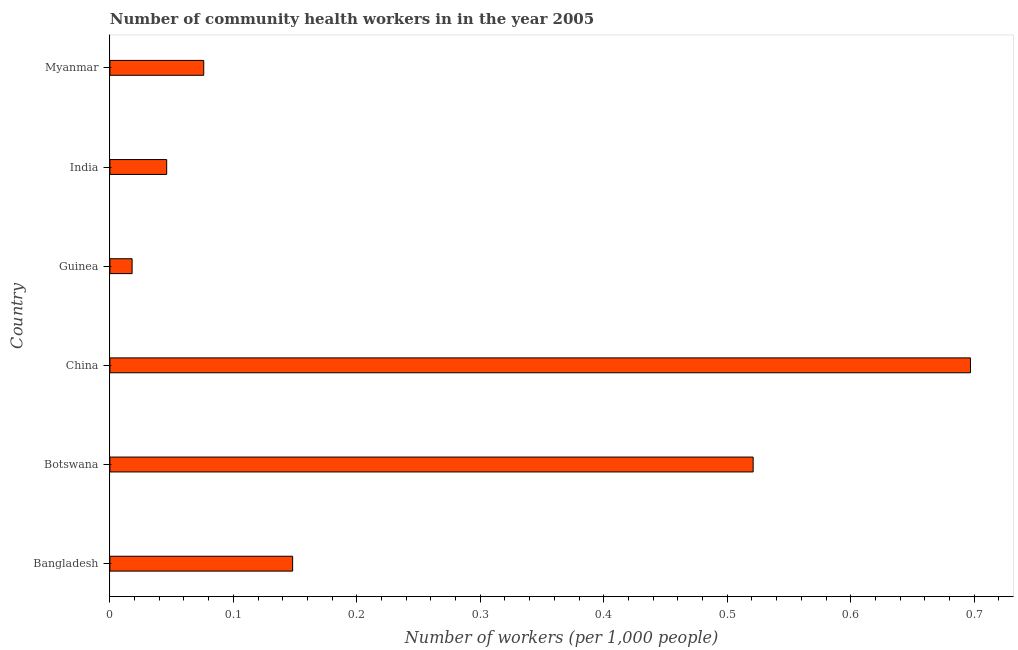Does the graph contain any zero values?
Give a very brief answer. No. What is the title of the graph?
Provide a short and direct response. Number of community health workers in in the year 2005. What is the label or title of the X-axis?
Provide a succinct answer. Number of workers (per 1,0 people). What is the label or title of the Y-axis?
Provide a succinct answer. Country. What is the number of community health workers in Guinea?
Your response must be concise. 0.02. Across all countries, what is the maximum number of community health workers?
Keep it short and to the point. 0.7. Across all countries, what is the minimum number of community health workers?
Ensure brevity in your answer.  0.02. In which country was the number of community health workers maximum?
Your response must be concise. China. In which country was the number of community health workers minimum?
Ensure brevity in your answer.  Guinea. What is the sum of the number of community health workers?
Offer a very short reply. 1.51. What is the difference between the number of community health workers in Bangladesh and Guinea?
Offer a terse response. 0.13. What is the average number of community health workers per country?
Your answer should be very brief. 0.25. What is the median number of community health workers?
Make the answer very short. 0.11. In how many countries, is the number of community health workers greater than 0.42 ?
Your response must be concise. 2. What is the ratio of the number of community health workers in Bangladesh to that in Myanmar?
Provide a succinct answer. 1.95. Is the number of community health workers in Botswana less than that in Guinea?
Your answer should be very brief. No. What is the difference between the highest and the second highest number of community health workers?
Your answer should be compact. 0.18. Is the sum of the number of community health workers in Bangladesh and Botswana greater than the maximum number of community health workers across all countries?
Give a very brief answer. No. What is the difference between the highest and the lowest number of community health workers?
Your response must be concise. 0.68. How many bars are there?
Your answer should be compact. 6. How many countries are there in the graph?
Make the answer very short. 6. Are the values on the major ticks of X-axis written in scientific E-notation?
Keep it short and to the point. No. What is the Number of workers (per 1,000 people) in Bangladesh?
Your answer should be very brief. 0.15. What is the Number of workers (per 1,000 people) in Botswana?
Offer a very short reply. 0.52. What is the Number of workers (per 1,000 people) of China?
Your answer should be compact. 0.7. What is the Number of workers (per 1,000 people) of Guinea?
Provide a succinct answer. 0.02. What is the Number of workers (per 1,000 people) of India?
Offer a very short reply. 0.05. What is the Number of workers (per 1,000 people) of Myanmar?
Your answer should be very brief. 0.08. What is the difference between the Number of workers (per 1,000 people) in Bangladesh and Botswana?
Keep it short and to the point. -0.37. What is the difference between the Number of workers (per 1,000 people) in Bangladesh and China?
Your response must be concise. -0.55. What is the difference between the Number of workers (per 1,000 people) in Bangladesh and Guinea?
Your answer should be compact. 0.13. What is the difference between the Number of workers (per 1,000 people) in Bangladesh and India?
Your answer should be compact. 0.1. What is the difference between the Number of workers (per 1,000 people) in Bangladesh and Myanmar?
Offer a terse response. 0.07. What is the difference between the Number of workers (per 1,000 people) in Botswana and China?
Give a very brief answer. -0.18. What is the difference between the Number of workers (per 1,000 people) in Botswana and Guinea?
Provide a succinct answer. 0.5. What is the difference between the Number of workers (per 1,000 people) in Botswana and India?
Provide a short and direct response. 0.47. What is the difference between the Number of workers (per 1,000 people) in Botswana and Myanmar?
Keep it short and to the point. 0.45. What is the difference between the Number of workers (per 1,000 people) in China and Guinea?
Ensure brevity in your answer.  0.68. What is the difference between the Number of workers (per 1,000 people) in China and India?
Your answer should be compact. 0.65. What is the difference between the Number of workers (per 1,000 people) in China and Myanmar?
Ensure brevity in your answer.  0.62. What is the difference between the Number of workers (per 1,000 people) in Guinea and India?
Provide a short and direct response. -0.03. What is the difference between the Number of workers (per 1,000 people) in Guinea and Myanmar?
Make the answer very short. -0.06. What is the difference between the Number of workers (per 1,000 people) in India and Myanmar?
Offer a very short reply. -0.03. What is the ratio of the Number of workers (per 1,000 people) in Bangladesh to that in Botswana?
Offer a very short reply. 0.28. What is the ratio of the Number of workers (per 1,000 people) in Bangladesh to that in China?
Offer a terse response. 0.21. What is the ratio of the Number of workers (per 1,000 people) in Bangladesh to that in Guinea?
Give a very brief answer. 8.22. What is the ratio of the Number of workers (per 1,000 people) in Bangladesh to that in India?
Ensure brevity in your answer.  3.22. What is the ratio of the Number of workers (per 1,000 people) in Bangladesh to that in Myanmar?
Your answer should be compact. 1.95. What is the ratio of the Number of workers (per 1,000 people) in Botswana to that in China?
Keep it short and to the point. 0.75. What is the ratio of the Number of workers (per 1,000 people) in Botswana to that in Guinea?
Offer a very short reply. 28.94. What is the ratio of the Number of workers (per 1,000 people) in Botswana to that in India?
Offer a terse response. 11.33. What is the ratio of the Number of workers (per 1,000 people) in Botswana to that in Myanmar?
Offer a very short reply. 6.86. What is the ratio of the Number of workers (per 1,000 people) in China to that in Guinea?
Provide a succinct answer. 38.72. What is the ratio of the Number of workers (per 1,000 people) in China to that in India?
Give a very brief answer. 15.15. What is the ratio of the Number of workers (per 1,000 people) in China to that in Myanmar?
Your answer should be compact. 9.17. What is the ratio of the Number of workers (per 1,000 people) in Guinea to that in India?
Offer a terse response. 0.39. What is the ratio of the Number of workers (per 1,000 people) in Guinea to that in Myanmar?
Provide a succinct answer. 0.24. What is the ratio of the Number of workers (per 1,000 people) in India to that in Myanmar?
Your response must be concise. 0.6. 